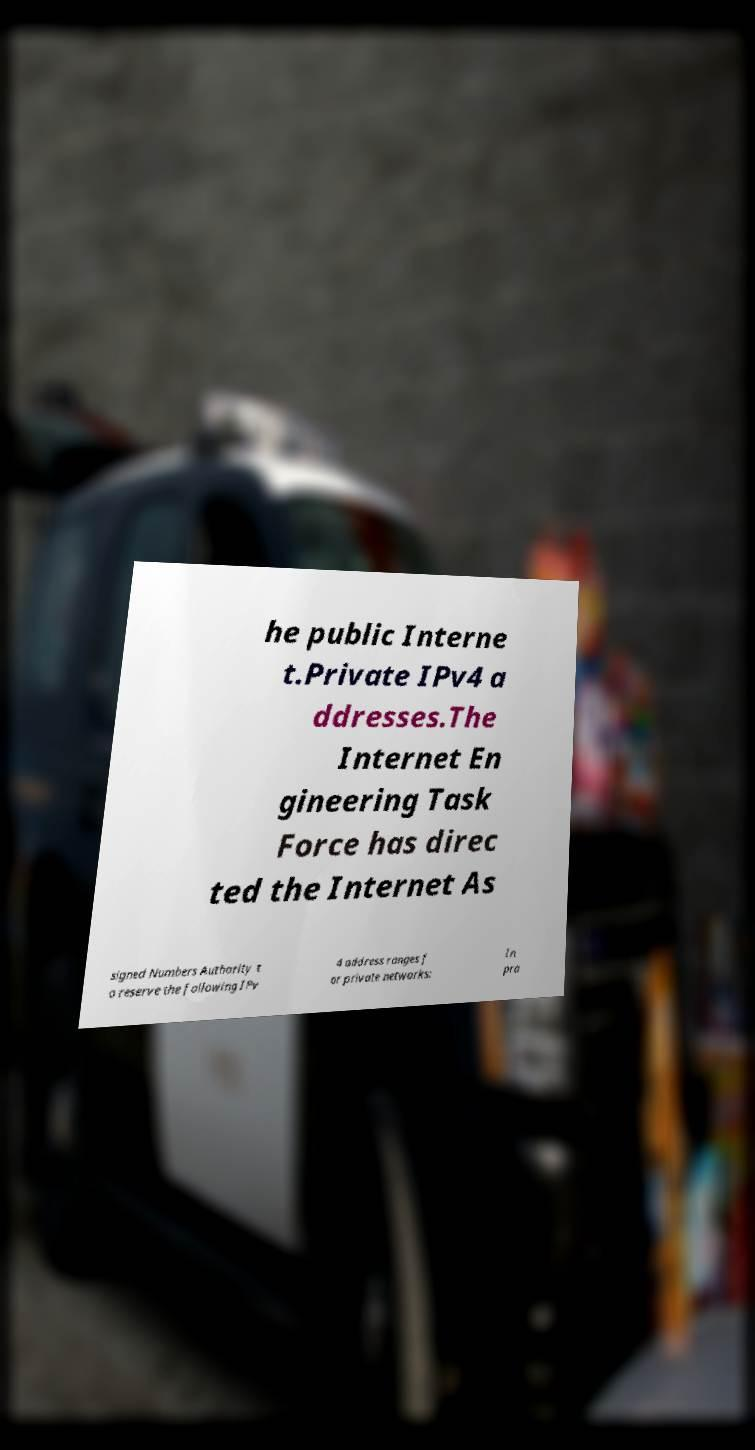Can you accurately transcribe the text from the provided image for me? he public Interne t.Private IPv4 a ddresses.The Internet En gineering Task Force has direc ted the Internet As signed Numbers Authority t o reserve the following IPv 4 address ranges f or private networks: In pra 